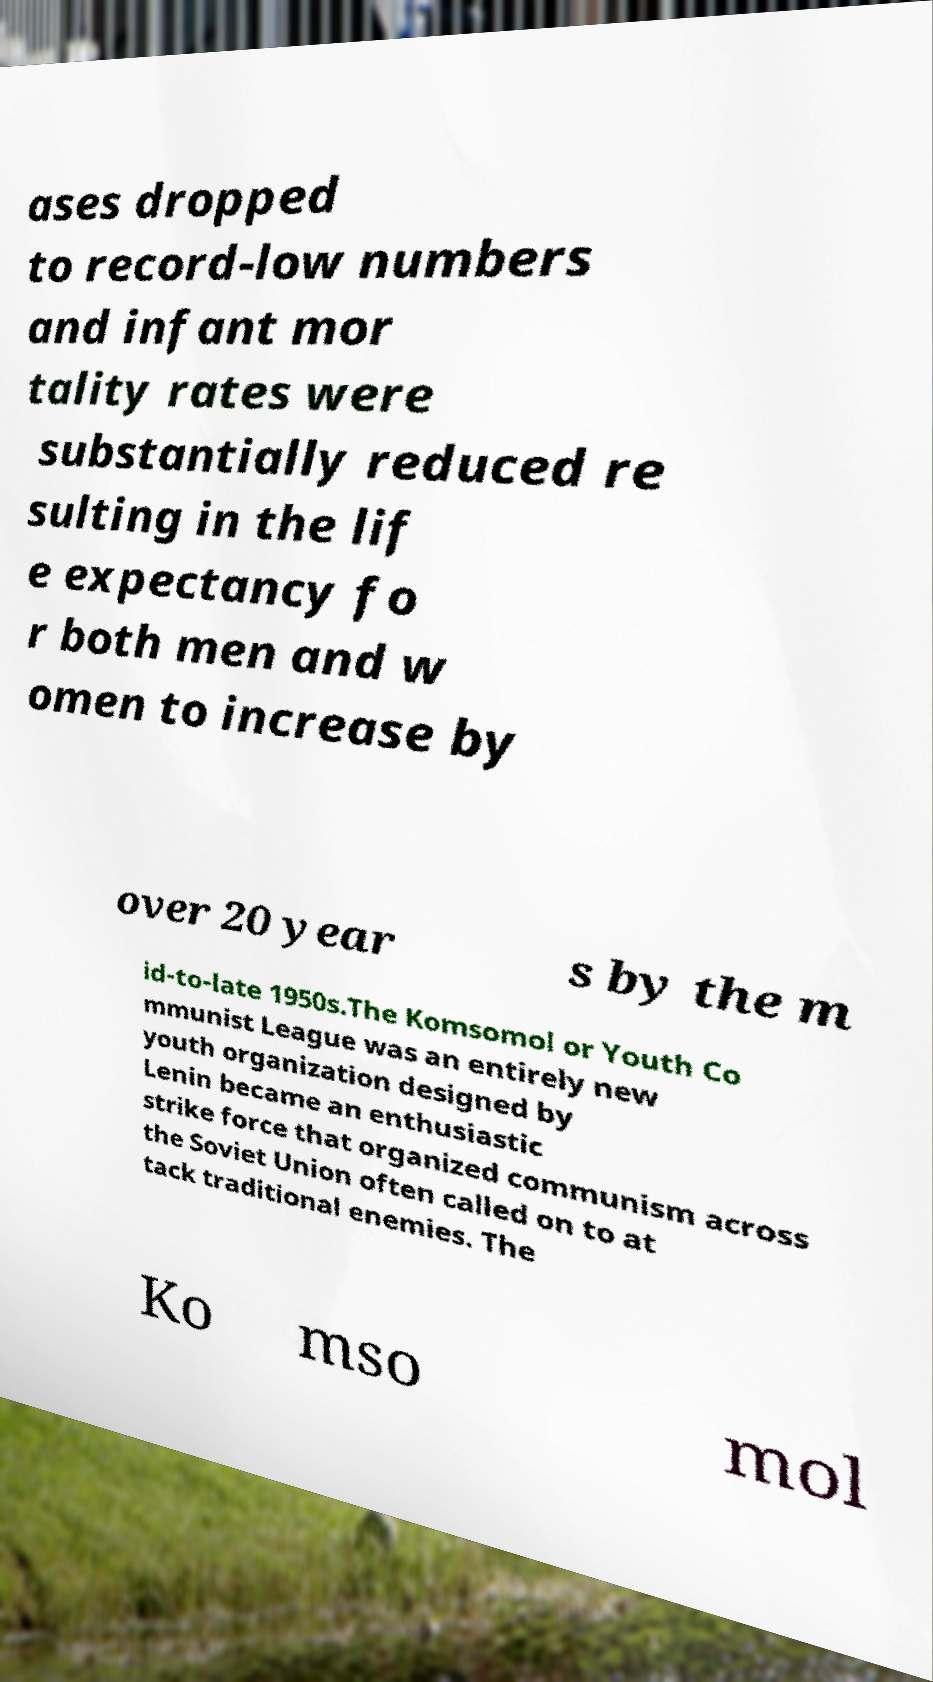Can you read and provide the text displayed in the image?This photo seems to have some interesting text. Can you extract and type it out for me? ases dropped to record-low numbers and infant mor tality rates were substantially reduced re sulting in the lif e expectancy fo r both men and w omen to increase by over 20 year s by the m id-to-late 1950s.The Komsomol or Youth Co mmunist League was an entirely new youth organization designed by Lenin became an enthusiastic strike force that organized communism across the Soviet Union often called on to at tack traditional enemies. The Ko mso mol 